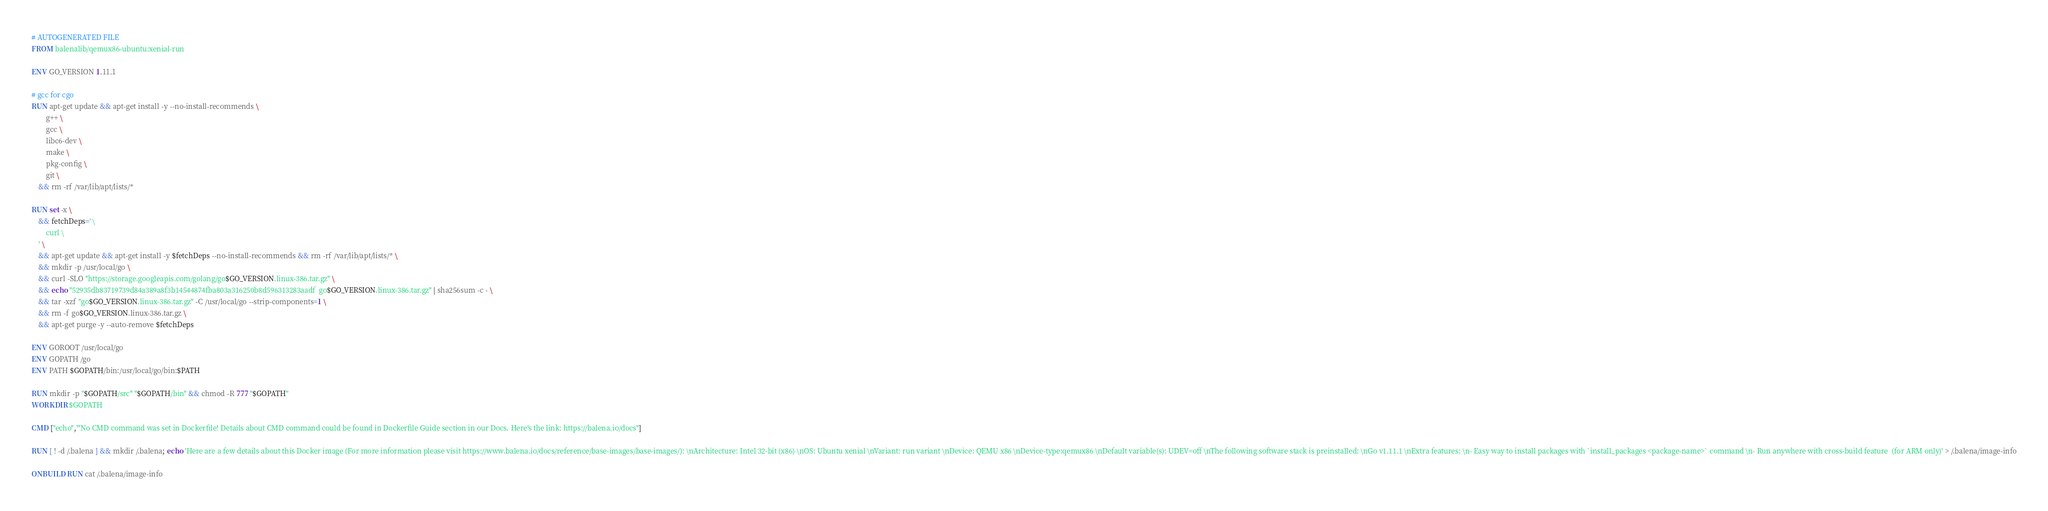Convert code to text. <code><loc_0><loc_0><loc_500><loc_500><_Dockerfile_># AUTOGENERATED FILE
FROM balenalib/qemux86-ubuntu:xenial-run

ENV GO_VERSION 1.11.1

# gcc for cgo
RUN apt-get update && apt-get install -y --no-install-recommends \
		g++ \
		gcc \
		libc6-dev \
		make \
		pkg-config \
		git \
	&& rm -rf /var/lib/apt/lists/*

RUN set -x \
	&& fetchDeps=' \
		curl \
	' \
	&& apt-get update && apt-get install -y $fetchDeps --no-install-recommends && rm -rf /var/lib/apt/lists/* \
	&& mkdir -p /usr/local/go \
	&& curl -SLO "https://storage.googleapis.com/golang/go$GO_VERSION.linux-386.tar.gz" \
	&& echo "52935db83719739d84a389a8f3b14544874fba803a316250b8d596313283aadf  go$GO_VERSION.linux-386.tar.gz" | sha256sum -c - \
	&& tar -xzf "go$GO_VERSION.linux-386.tar.gz" -C /usr/local/go --strip-components=1 \
	&& rm -f go$GO_VERSION.linux-386.tar.gz \
	&& apt-get purge -y --auto-remove $fetchDeps

ENV GOROOT /usr/local/go
ENV GOPATH /go
ENV PATH $GOPATH/bin:/usr/local/go/bin:$PATH

RUN mkdir -p "$GOPATH/src" "$GOPATH/bin" && chmod -R 777 "$GOPATH"
WORKDIR $GOPATH

CMD ["echo","'No CMD command was set in Dockerfile! Details about CMD command could be found in Dockerfile Guide section in our Docs. Here's the link: https://balena.io/docs"]

RUN [ ! -d /.balena ] && mkdir /.balena; echo 'Here are a few details about this Docker image (For more information please visit https://www.balena.io/docs/reference/base-images/base-images/): \nArchitecture: Intel 32-bit (x86) \nOS: Ubuntu xenial \nVariant: run variant \nDevice: QEMU x86 \nDevice-type:qemux86 \nDefault variable(s): UDEV=off \nThe following software stack is preinstalled: \nGo v1.11.1 \nExtra features: \n- Easy way to install packages with `install_packages <package-name>` command \n- Run anywhere with cross-build feature  (for ARM only)' > /.balena/image-info

ONBUILD RUN cat /.balena/image-info</code> 